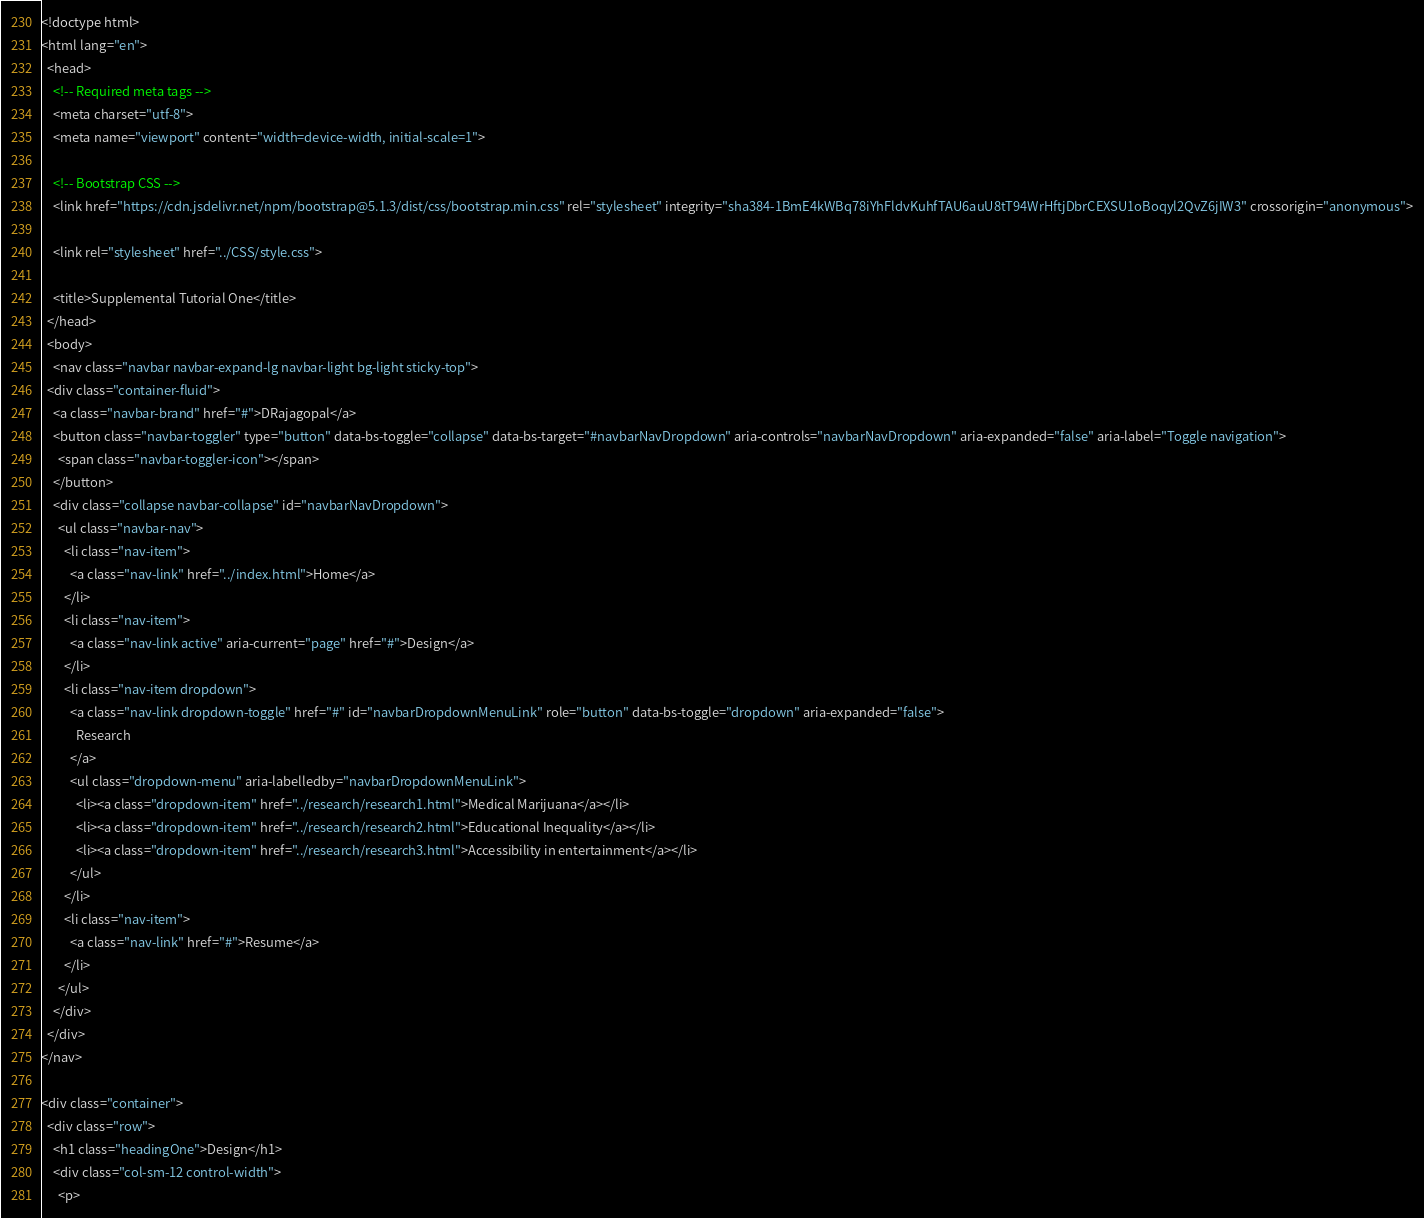<code> <loc_0><loc_0><loc_500><loc_500><_HTML_><!doctype html>
<html lang="en">
  <head>
    <!-- Required meta tags -->
    <meta charset="utf-8">
    <meta name="viewport" content="width=device-width, initial-scale=1">

    <!-- Bootstrap CSS -->
    <link href="https://cdn.jsdelivr.net/npm/bootstrap@5.1.3/dist/css/bootstrap.min.css" rel="stylesheet" integrity="sha384-1BmE4kWBq78iYhFldvKuhfTAU6auU8tT94WrHftjDbrCEXSU1oBoqyl2QvZ6jIW3" crossorigin="anonymous">

    <link rel="stylesheet" href="../CSS/style.css">

    <title>Supplemental Tutorial One</title>
  </head>
  <body>
    <nav class="navbar navbar-expand-lg navbar-light bg-light sticky-top">
  <div class="container-fluid">
    <a class="navbar-brand" href="#">DRajagopal</a>
    <button class="navbar-toggler" type="button" data-bs-toggle="collapse" data-bs-target="#navbarNavDropdown" aria-controls="navbarNavDropdown" aria-expanded="false" aria-label="Toggle navigation">
      <span class="navbar-toggler-icon"></span>
    </button>
    <div class="collapse navbar-collapse" id="navbarNavDropdown">
      <ul class="navbar-nav">
        <li class="nav-item">
          <a class="nav-link" href="../index.html">Home</a>
        </li>
        <li class="nav-item">
          <a class="nav-link active" aria-current="page" href="#">Design</a>
        </li>
        <li class="nav-item dropdown">
          <a class="nav-link dropdown-toggle" href="#" id="navbarDropdownMenuLink" role="button" data-bs-toggle="dropdown" aria-expanded="false">
            Research
          </a>
          <ul class="dropdown-menu" aria-labelledby="navbarDropdownMenuLink">
            <li><a class="dropdown-item" href="../research/research1.html">Medical Marijuana</a></li>
            <li><a class="dropdown-item" href="../research/research2.html">Educational Inequality</a></li>
            <li><a class="dropdown-item" href="../research/research3.html">Accessibility in entertainment</a></li>
          </ul>
        </li>
        <li class="nav-item">
          <a class="nav-link" href="#">Resume</a>
        </li>
      </ul>
    </div>
  </div>
</nav>

<div class="container">
  <div class="row">
    <h1 class="headingOne">Design</h1>
    <div class="col-sm-12 control-width">
      <p></code> 